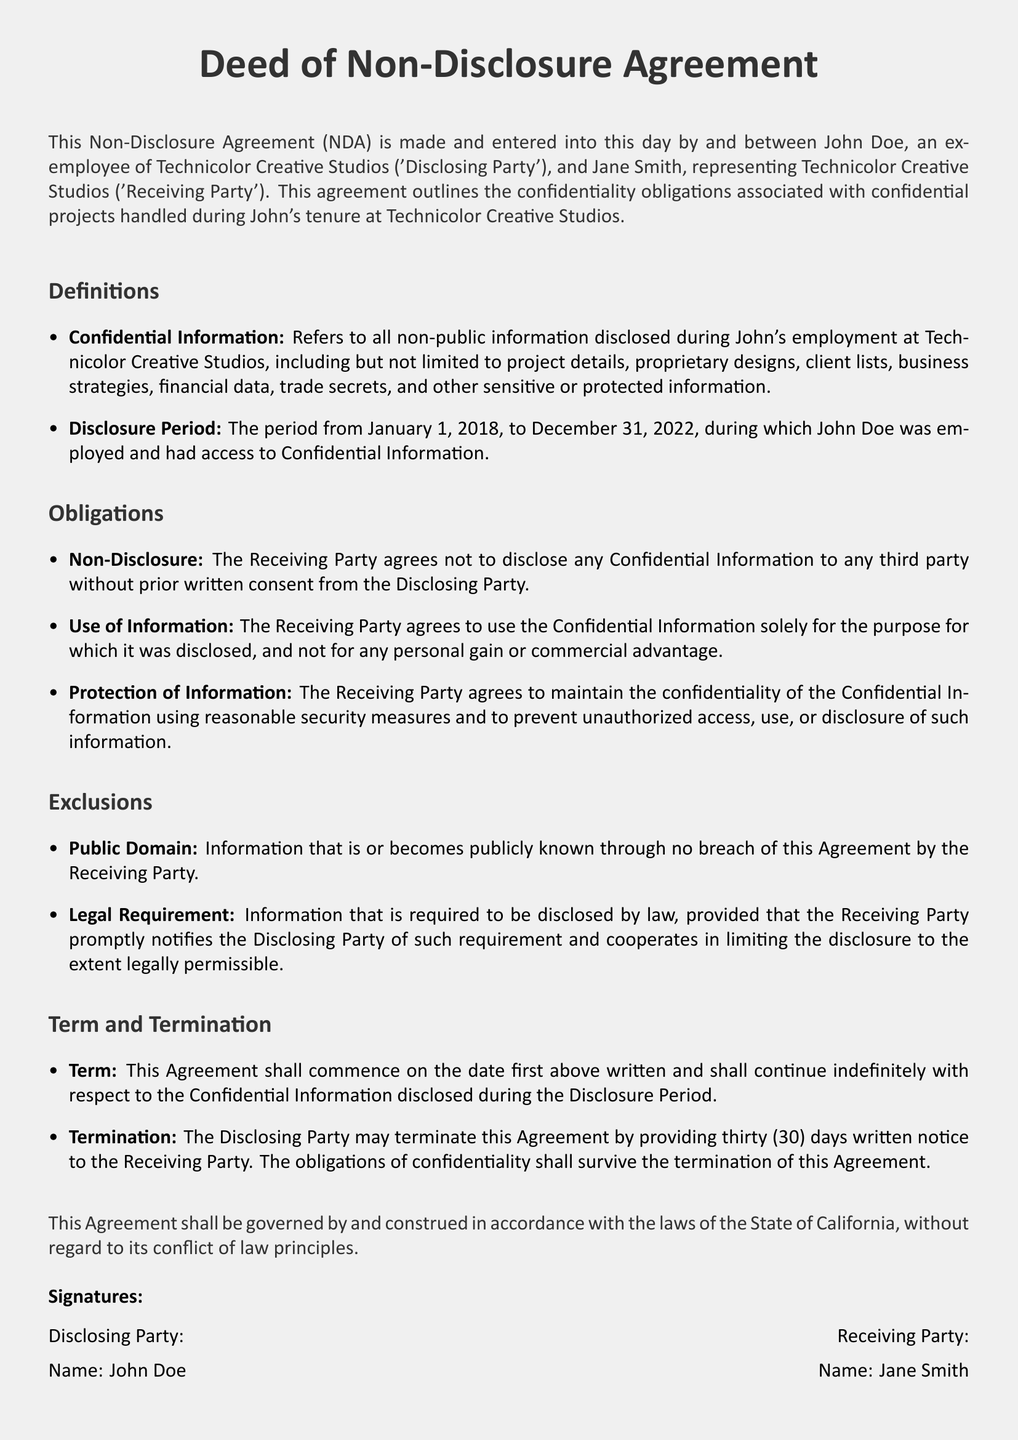What is the name of the Disclosing Party? The Disclosing Party is identified as John Doe, an ex-employee of Technicolor Creative Studios.
Answer: John Doe What is the name of the Receiving Party? The Receiving Party is represented by Jane Smith, who is associated with Technicolor Creative Studios.
Answer: Jane Smith What is the Disclosure Period? The Disclosure Period refers to the time frame when John Doe was employed and had access to Confidential Information, which is specified in the document.
Answer: January 1, 2018, to December 31, 2022 What must the Receiving Party do with the Confidential Information? The document states that the Receiving Party agrees to use the Confidential Information solely for the purposes for which it was disclosed.
Answer: Only for the purpose for which it was disclosed What is the term of the agreement? The term of the agreement is specified as commencing on the date written and continuing indefinitely with respect to the Confidential Information disclosed during the Disclosure Period.
Answer: Indefinitely How much notice must the Disclosing Party provide to terminate the agreement? The document specifies that thirty days written notice is required from the Disclosing Party to terminate the agreement.
Answer: Thirty (30) days What type of law governs this agreement? The document indicates that the agreement shall be governed by the laws of a specific state.
Answer: The laws of the State of California What information is excluded from confidentiality obligations? The exclusions specify categories of information that are not subject to confidentiality obligations, including information publicly known and legally required disclosures.
Answer: Public Domain and Legal Requirement What is the purpose of this Deed? The purpose outlined in the Deed is to establish confidentiality obligations associated with projects handled during the Disclosing Party's employment.
Answer: To establish confidentiality obligations 